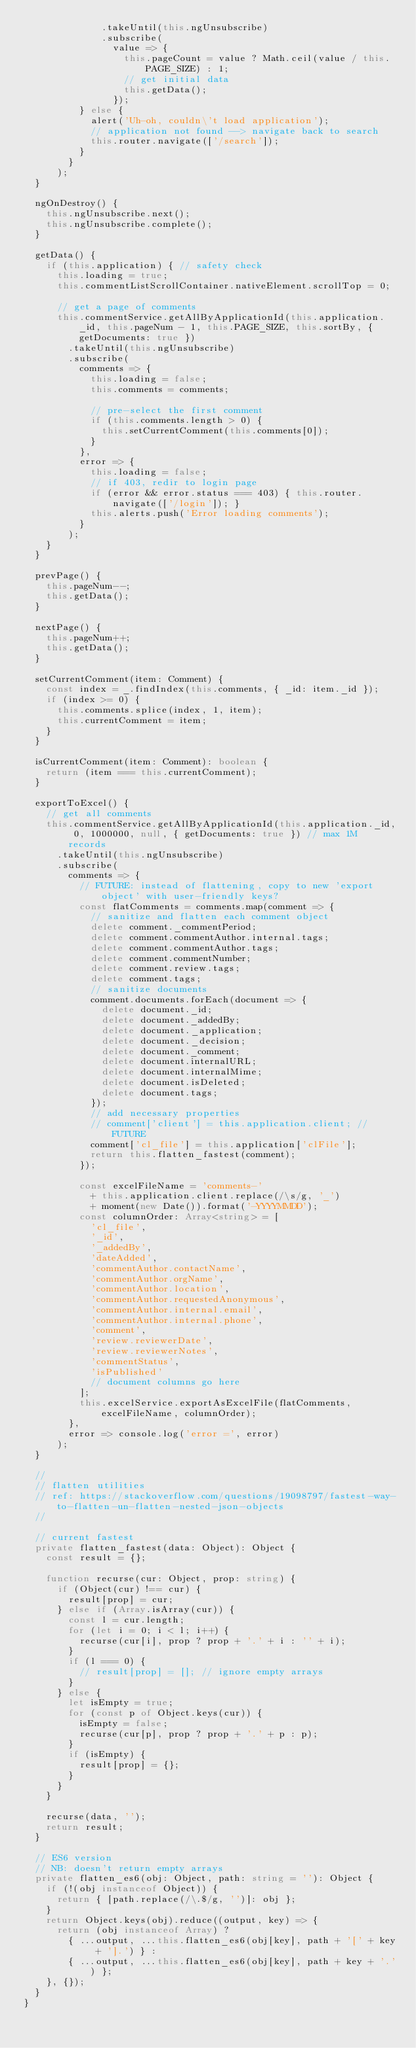<code> <loc_0><loc_0><loc_500><loc_500><_TypeScript_>              .takeUntil(this.ngUnsubscribe)
              .subscribe(
                value => {
                  this.pageCount = value ? Math.ceil(value / this.PAGE_SIZE) : 1;
                  // get initial data
                  this.getData();
                });
          } else {
            alert('Uh-oh, couldn\'t load application');
            // application not found --> navigate back to search
            this.router.navigate(['/search']);
          }
        }
      );
  }

  ngOnDestroy() {
    this.ngUnsubscribe.next();
    this.ngUnsubscribe.complete();
  }

  getData() {
    if (this.application) { // safety check
      this.loading = true;
      this.commentListScrollContainer.nativeElement.scrollTop = 0;

      // get a page of comments
      this.commentService.getAllByApplicationId(this.application._id, this.pageNum - 1, this.PAGE_SIZE, this.sortBy, { getDocuments: true })
        .takeUntil(this.ngUnsubscribe)
        .subscribe(
          comments => {
            this.loading = false;
            this.comments = comments;

            // pre-select the first comment
            if (this.comments.length > 0) {
              this.setCurrentComment(this.comments[0]);
            }
          },
          error => {
            this.loading = false;
            // if 403, redir to login page
            if (error && error.status === 403) { this.router.navigate(['/login']); }
            this.alerts.push('Error loading comments');
          }
        );
    }
  }

  prevPage() {
    this.pageNum--;
    this.getData();
  }

  nextPage() {
    this.pageNum++;
    this.getData();
  }

  setCurrentComment(item: Comment) {
    const index = _.findIndex(this.comments, { _id: item._id });
    if (index >= 0) {
      this.comments.splice(index, 1, item);
      this.currentComment = item;
    }
  }

  isCurrentComment(item: Comment): boolean {
    return (item === this.currentComment);
  }

  exportToExcel() {
    // get all comments
    this.commentService.getAllByApplicationId(this.application._id, 0, 1000000, null, { getDocuments: true }) // max 1M records
      .takeUntil(this.ngUnsubscribe)
      .subscribe(
        comments => {
          // FUTURE: instead of flattening, copy to new 'export object' with user-friendly keys?
          const flatComments = comments.map(comment => {
            // sanitize and flatten each comment object
            delete comment._commentPeriod;
            delete comment.commentAuthor.internal.tags;
            delete comment.commentAuthor.tags;
            delete comment.commentNumber;
            delete comment.review.tags;
            delete comment.tags;
            // sanitize documents
            comment.documents.forEach(document => {
              delete document._id;
              delete document._addedBy;
              delete document._application;
              delete document._decision;
              delete document._comment;
              delete document.internalURL;
              delete document.internalMime;
              delete document.isDeleted;
              delete document.tags;
            });
            // add necessary properties
            // comment['client'] = this.application.client; // FUTURE
            comment['cl_file'] = this.application['clFile'];
            return this.flatten_fastest(comment);
          });

          const excelFileName = 'comments-'
            + this.application.client.replace(/\s/g, '_')
            + moment(new Date()).format('-YYYYMMDD');
          const columnOrder: Array<string> = [
            'cl_file',
            '_id',
            '_addedBy',
            'dateAdded',
            'commentAuthor.contactName',
            'commentAuthor.orgName',
            'commentAuthor.location',
            'commentAuthor.requestedAnonymous',
            'commentAuthor.internal.email',
            'commentAuthor.internal.phone',
            'comment',
            'review.reviewerDate',
            'review.reviewerNotes',
            'commentStatus',
            'isPublished'
            // document columns go here
          ];
          this.excelService.exportAsExcelFile(flatComments, excelFileName, columnOrder);
        },
        error => console.log('error =', error)
      );
  }

  //
  // flatten utilities
  // ref: https://stackoverflow.com/questions/19098797/fastest-way-to-flatten-un-flatten-nested-json-objects
  //

  // current fastest
  private flatten_fastest(data: Object): Object {
    const result = {};

    function recurse(cur: Object, prop: string) {
      if (Object(cur) !== cur) {
        result[prop] = cur;
      } else if (Array.isArray(cur)) {
        const l = cur.length;
        for (let i = 0; i < l; i++) {
          recurse(cur[i], prop ? prop + '.' + i : '' + i);
        }
        if (l === 0) {
          // result[prop] = []; // ignore empty arrays
        }
      } else {
        let isEmpty = true;
        for (const p of Object.keys(cur)) {
          isEmpty = false;
          recurse(cur[p], prop ? prop + '.' + p : p);
        }
        if (isEmpty) {
          result[prop] = {};
        }
      }
    }

    recurse(data, '');
    return result;
  }

  // ES6 version
  // NB: doesn't return empty arrays
  private flatten_es6(obj: Object, path: string = ''): Object {
    if (!(obj instanceof Object)) {
      return { [path.replace(/\.$/g, '')]: obj };
    }
    return Object.keys(obj).reduce((output, key) => {
      return (obj instanceof Array) ?
        { ...output, ...this.flatten_es6(obj[key], path + '[' + key + '].') } :
        { ...output, ...this.flatten_es6(obj[key], path + key + '.') };
    }, {});
  }
}
</code> 